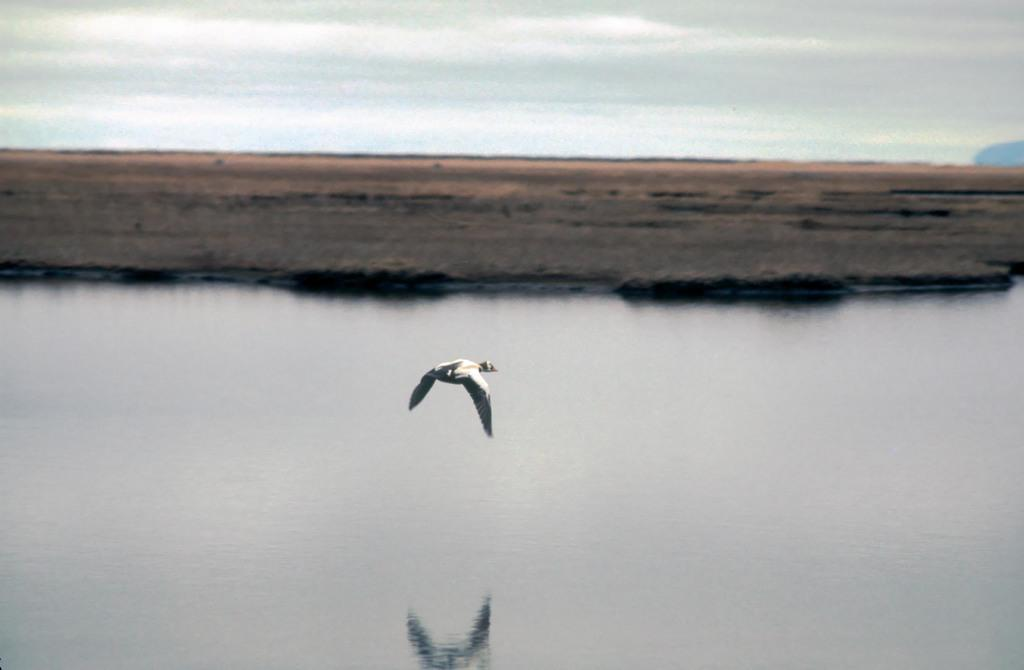What is located in the foreground of the image? There is a water body and a bird in the foreground of the image. What type of environment is depicted in the background of the image? The background of the image appears to be a forest. What is visible at the top of the image? The sky is visible at the top of the image. Can you tell me how the kitty is feeling in the image? There is no kitty present in the image. What type of scarecrow can be seen in the image? There is no scarecrow present in the image. 